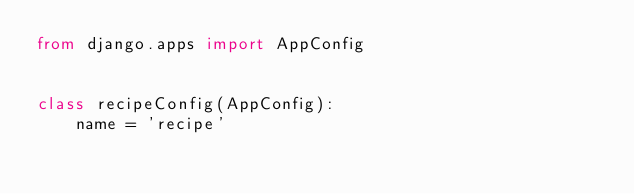<code> <loc_0><loc_0><loc_500><loc_500><_Python_>from django.apps import AppConfig


class recipeConfig(AppConfig):
    name = 'recipe'
</code> 